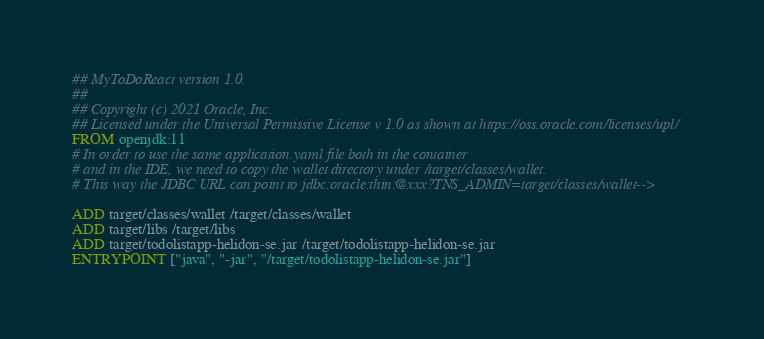Convert code to text. <code><loc_0><loc_0><loc_500><loc_500><_Dockerfile_>## MyToDoReact version 1.0.
##
## Copyright (c) 2021 Oracle, Inc.
## Licensed under the Universal Permissive License v 1.0 as shown at https://oss.oracle.com/licenses/upl/
FROM openjdk:11
# In order to use the same application.yaml file both in the container
# and in the IDE, we need to copy the wallet directory under /target/classes/wallet.
# This way the JDBC URL can point to jdbc:oracle:thin:@xxx?TNS_ADMIN=target/classes/wallet-->

ADD target/classes/wallet /target/classes/wallet
ADD target/libs /target/libs
ADD target/todolistapp-helidon-se.jar /target/todolistapp-helidon-se.jar
ENTRYPOINT ["java", "-jar", "/target/todolistapp-helidon-se.jar"]
</code> 